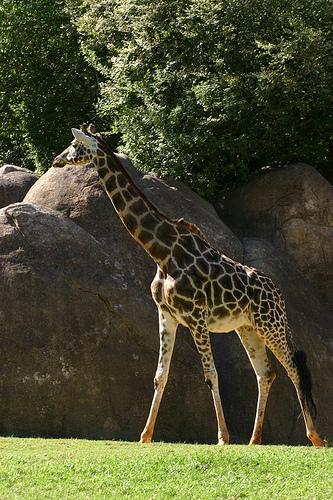Is the giraffe showing off?
Short answer required. No. Is it snowing?
Concise answer only. No. Is this a baby giraffe?
Concise answer only. Yes. Is the animal taller than the plant in the background?
Short answer required. No. 